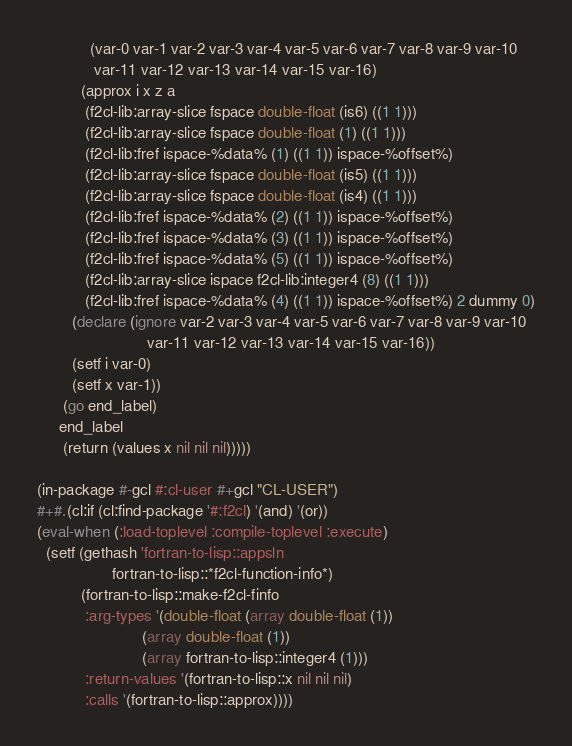Convert code to text. <code><loc_0><loc_0><loc_500><loc_500><_Lisp_>            (var-0 var-1 var-2 var-3 var-4 var-5 var-6 var-7 var-8 var-9 var-10
             var-11 var-12 var-13 var-14 var-15 var-16)
          (approx i x z a
           (f2cl-lib:array-slice fspace double-float (is6) ((1 1)))
           (f2cl-lib:array-slice fspace double-float (1) ((1 1)))
           (f2cl-lib:fref ispace-%data% (1) ((1 1)) ispace-%offset%)
           (f2cl-lib:array-slice fspace double-float (is5) ((1 1)))
           (f2cl-lib:array-slice fspace double-float (is4) ((1 1)))
           (f2cl-lib:fref ispace-%data% (2) ((1 1)) ispace-%offset%)
           (f2cl-lib:fref ispace-%data% (3) ((1 1)) ispace-%offset%)
           (f2cl-lib:fref ispace-%data% (5) ((1 1)) ispace-%offset%)
           (f2cl-lib:array-slice ispace f2cl-lib:integer4 (8) ((1 1)))
           (f2cl-lib:fref ispace-%data% (4) ((1 1)) ispace-%offset%) 2 dummy 0)
        (declare (ignore var-2 var-3 var-4 var-5 var-6 var-7 var-8 var-9 var-10
                         var-11 var-12 var-13 var-14 var-15 var-16))
        (setf i var-0)
        (setf x var-1))
      (go end_label)
     end_label
      (return (values x nil nil nil)))))

(in-package #-gcl #:cl-user #+gcl "CL-USER")
#+#.(cl:if (cl:find-package '#:f2cl) '(and) '(or))
(eval-when (:load-toplevel :compile-toplevel :execute)
  (setf (gethash 'fortran-to-lisp::appsln
                 fortran-to-lisp::*f2cl-function-info*)
          (fortran-to-lisp::make-f2cl-finfo
           :arg-types '(double-float (array double-float (1))
                        (array double-float (1))
                        (array fortran-to-lisp::integer4 (1)))
           :return-values '(fortran-to-lisp::x nil nil nil)
           :calls '(fortran-to-lisp::approx))))

</code> 